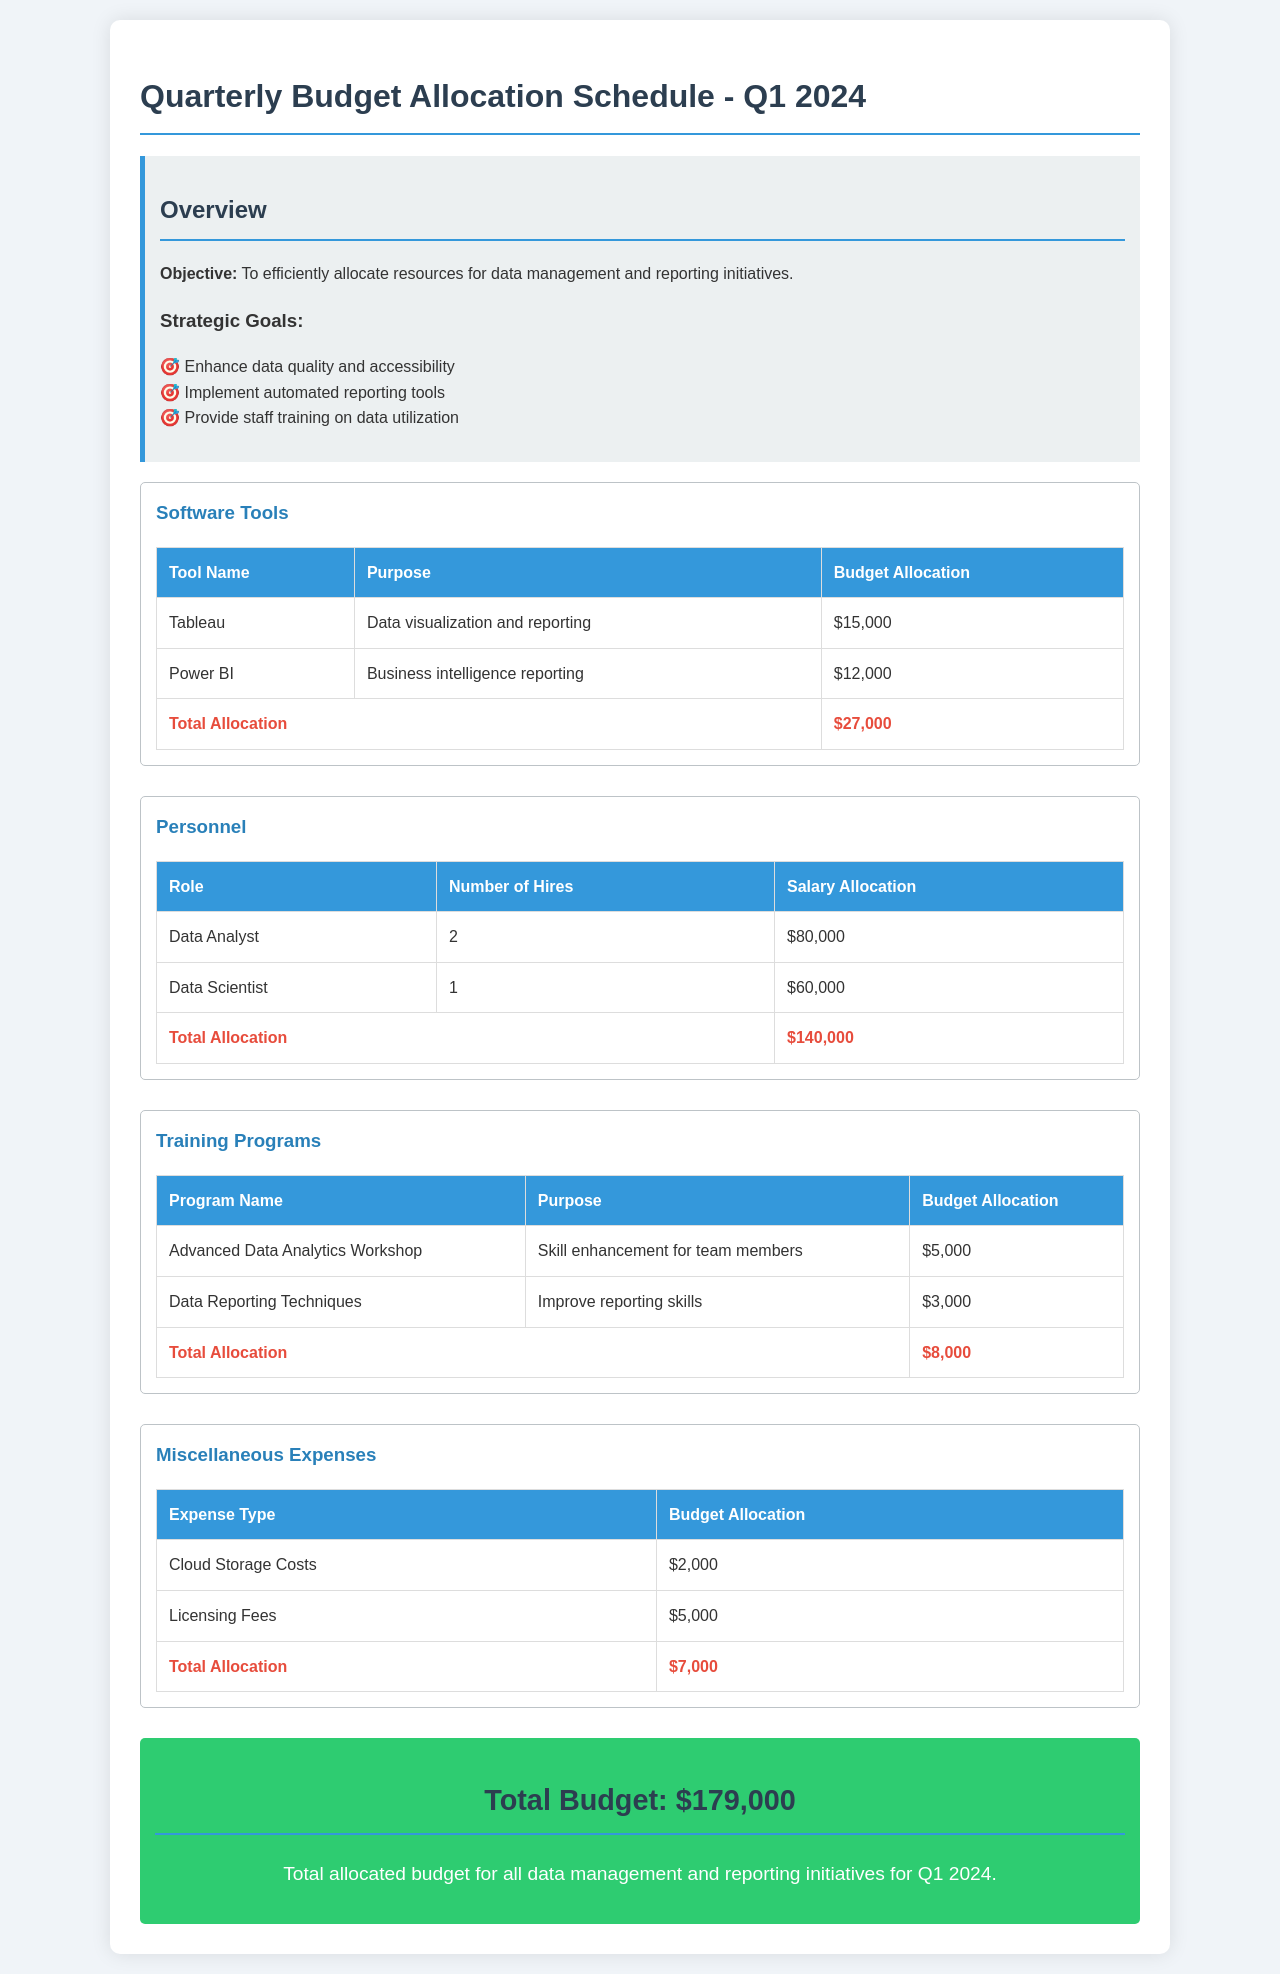What is the total budget allocation for Q1 2024? The total budget for Q1 2024 is located at the bottom of the document and is the sum of all categories, which is $179,000.
Answer: $179,000 How much is allocated for Tableau? The allocation for Tableau is listed under Software Tools in the document.
Answer: $15,000 How many Data Analysts are included in the personnel budget? The number of Data Analysts is found in the Personnel category of the document.
Answer: 2 What is the purpose of the Advanced Data Analytics Workshop? The purpose is stated next to the program name in the Training Programs section.
Answer: Skill enhancement for team members Which category has the highest budget allocation? By comparing the totals, you can determine which category has the largest allocation, found in the totals for each category.
Answer: Personnel What are the strategic goals outlined in the document? The strategic goals are listed in the Overview section, detailing the main objectives for the budget allocation.
Answer: Enhance data quality and accessibility, Implement automated reporting tools, Provide staff training on data utilization How much is allocated for Licensing Fees in Miscellaneous Expenses? The Licensing Fees amount can be found in the Miscellaneous Expenses table in the document.
Answer: $5,000 Which tool is allocated the least budget in the Software Tools category? The tool with the least allocation would be determined by comparing the budget amounts for Tableau and Power BI.
Answer: Power BI 